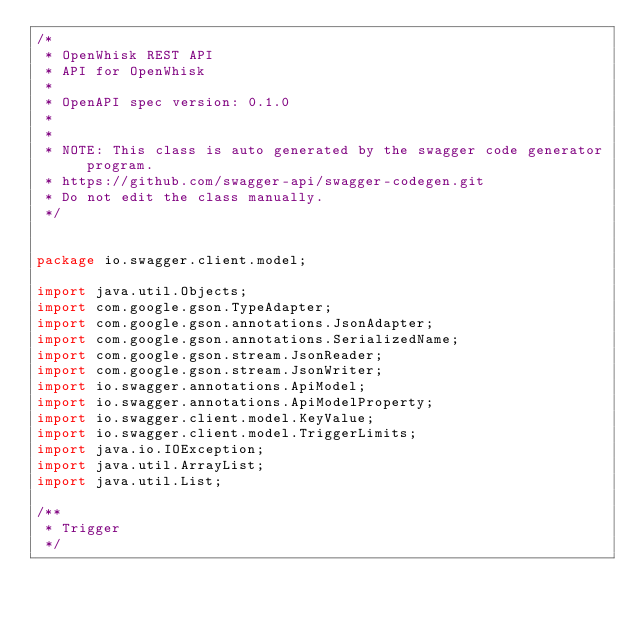Convert code to text. <code><loc_0><loc_0><loc_500><loc_500><_Java_>/*
 * OpenWhisk REST API
 * API for OpenWhisk
 *
 * OpenAPI spec version: 0.1.0
 * 
 *
 * NOTE: This class is auto generated by the swagger code generator program.
 * https://github.com/swagger-api/swagger-codegen.git
 * Do not edit the class manually.
 */


package io.swagger.client.model;

import java.util.Objects;
import com.google.gson.TypeAdapter;
import com.google.gson.annotations.JsonAdapter;
import com.google.gson.annotations.SerializedName;
import com.google.gson.stream.JsonReader;
import com.google.gson.stream.JsonWriter;
import io.swagger.annotations.ApiModel;
import io.swagger.annotations.ApiModelProperty;
import io.swagger.client.model.KeyValue;
import io.swagger.client.model.TriggerLimits;
import java.io.IOException;
import java.util.ArrayList;
import java.util.List;

/**
 * Trigger
 */</code> 